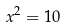Convert formula to latex. <formula><loc_0><loc_0><loc_500><loc_500>x ^ { 2 } = 1 0</formula> 